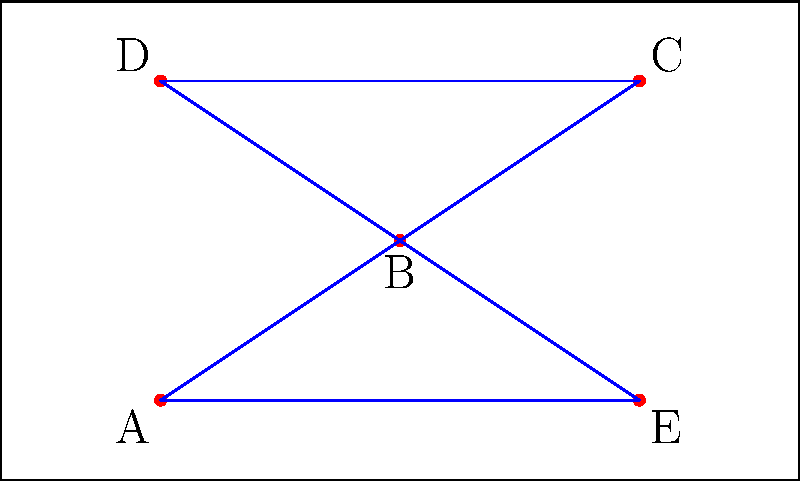You have a rectangular campaign area measuring 10 units wide by 6 units high. Five optimal locations (A, B, C, D, E) have been identified for placing campaign signs. To maximize visibility and minimize interference, you need to connect these points with the shortest possible path. What is the total length of this optimal path? To find the shortest path connecting all points, we need to solve the Traveling Salesman Problem (TSP) for these five points. However, for this specific configuration, we can use spatial reasoning to determine the optimal path:

1. Calculate the distances between all pairs of points using the distance formula: $d = \sqrt{(x_2-x_1)^2 + (y_2-y_1)^2}$

2. Observe that the points form a pentagonal shape. The shortest path will likely follow the perimeter of this pentagon.

3. Calculate the perimeter of the pentagon:
   AB = $\sqrt{(5-2)^2 + (3-1)^2} = \sqrt{13}$
   BC = $\sqrt{(8-5)^2 + (5-3)^2} = \sqrt{13}$
   CD = $\sqrt{(2-8)^2 + (5-5)^2} = 6$
   DE = $\sqrt{(8-2)^2 + (1-5)^2} = \sqrt{52}$
   EA = $\sqrt{(2-8)^2 + (1-1)^2} = 6$

4. Sum up the distances:
   Total length = $\sqrt{13} + \sqrt{13} + 6 + \sqrt{52} + 6$

5. Simplify:
   $= 2\sqrt{13} + \sqrt{52} + 12$
   $= 2\sqrt{13} + 2\sqrt{13} + 12$
   $= 4\sqrt{13} + 12$

Therefore, the optimal path length is $4\sqrt{13} + 12$ units.
Answer: $4\sqrt{13} + 12$ units 